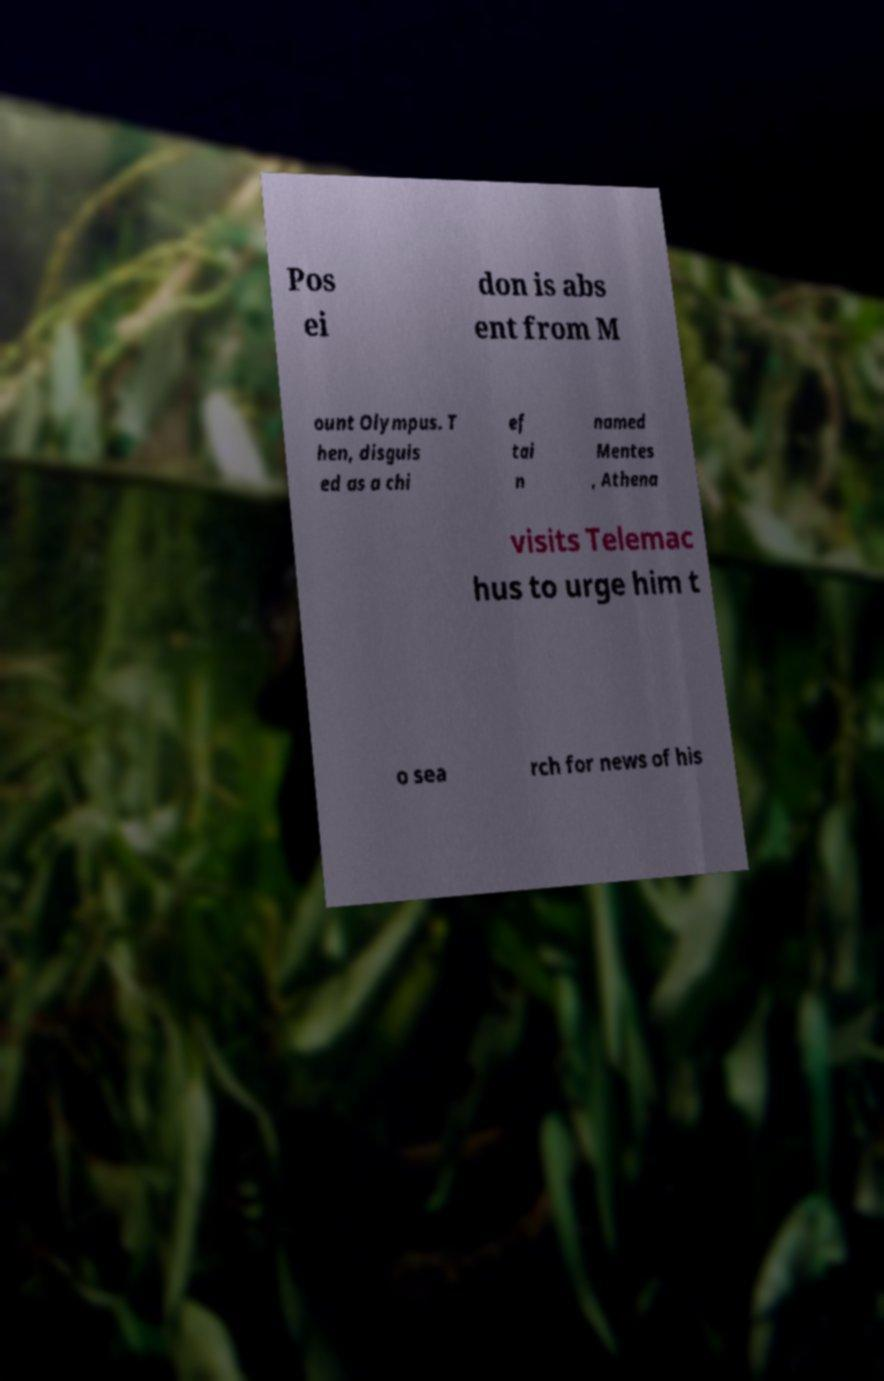Could you assist in decoding the text presented in this image and type it out clearly? Pos ei don is abs ent from M ount Olympus. T hen, disguis ed as a chi ef tai n named Mentes , Athena visits Telemac hus to urge him t o sea rch for news of his 